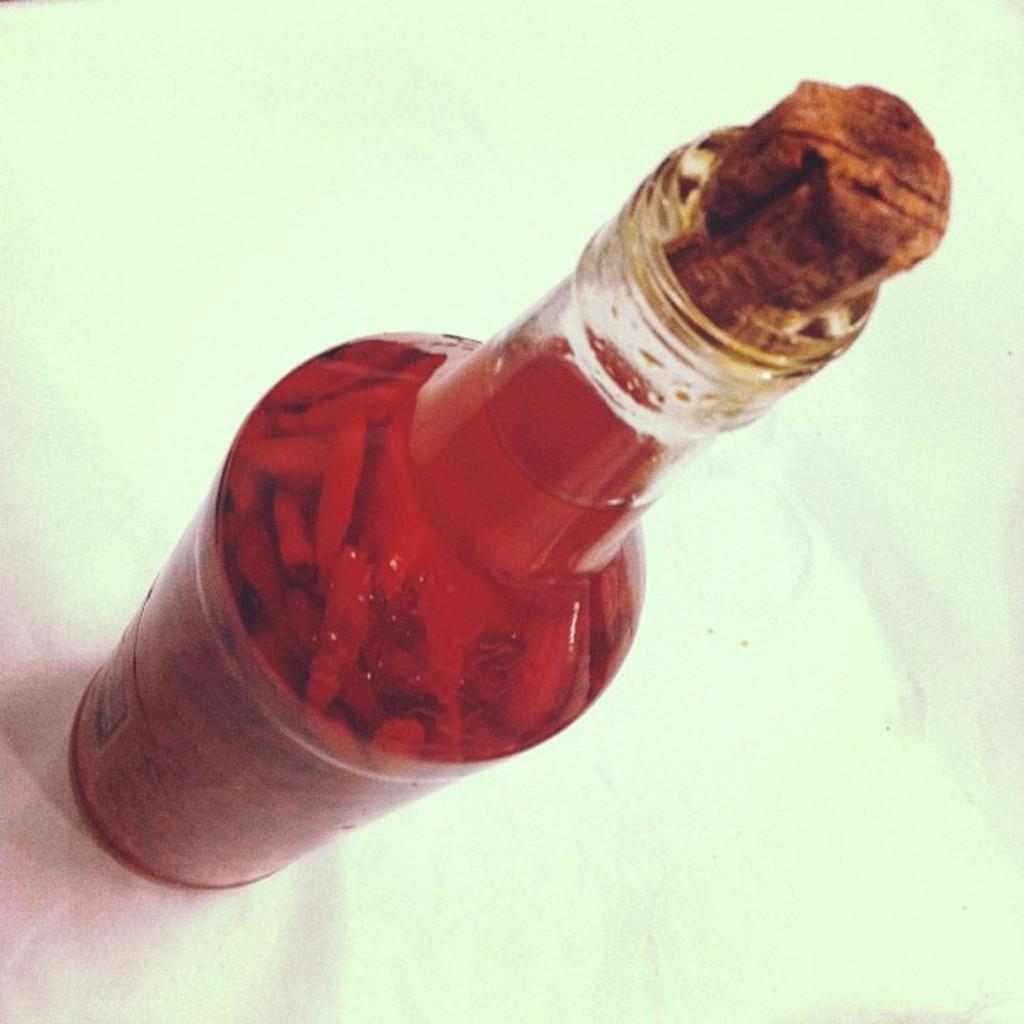What object is present in the image that contains liquid? There is a bottle in the image that contains liquid. What type of particles can be seen in the liquid inside the bottle? There are particles in the liquid inside the bottle. How is the bottle sealed or closed? The bottle is closed with a small wooden piece. What type of cord is used to tie the grape in the image? There is no grape present in the image, so it is not possible to determine what type of cord might be used to tie it. 